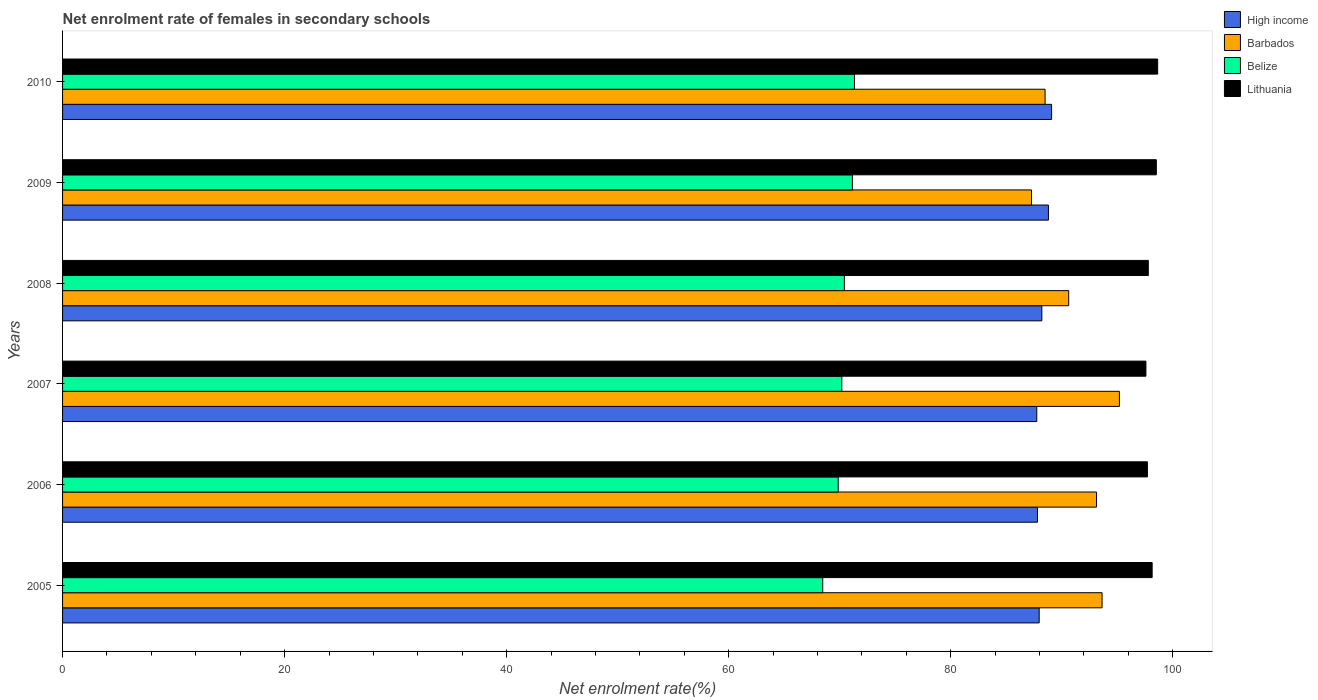How many groups of bars are there?
Provide a succinct answer. 6. Are the number of bars per tick equal to the number of legend labels?
Your response must be concise. Yes. Are the number of bars on each tick of the Y-axis equal?
Your answer should be very brief. Yes. How many bars are there on the 2nd tick from the bottom?
Provide a short and direct response. 4. What is the net enrolment rate of females in secondary schools in Barbados in 2008?
Ensure brevity in your answer.  90.63. Across all years, what is the maximum net enrolment rate of females in secondary schools in High income?
Keep it short and to the point. 89.08. Across all years, what is the minimum net enrolment rate of females in secondary schools in Lithuania?
Your answer should be compact. 97.58. In which year was the net enrolment rate of females in secondary schools in Belize minimum?
Ensure brevity in your answer.  2005. What is the total net enrolment rate of females in secondary schools in High income in the graph?
Give a very brief answer. 529.62. What is the difference between the net enrolment rate of females in secondary schools in Barbados in 2006 and that in 2010?
Offer a very short reply. 4.63. What is the difference between the net enrolment rate of females in secondary schools in High income in 2006 and the net enrolment rate of females in secondary schools in Barbados in 2009?
Give a very brief answer. 0.54. What is the average net enrolment rate of females in secondary schools in Lithuania per year?
Your answer should be very brief. 98.07. In the year 2009, what is the difference between the net enrolment rate of females in secondary schools in Belize and net enrolment rate of females in secondary schools in Barbados?
Offer a terse response. -16.13. What is the ratio of the net enrolment rate of females in secondary schools in High income in 2005 to that in 2006?
Give a very brief answer. 1. Is the net enrolment rate of females in secondary schools in Barbados in 2005 less than that in 2008?
Your answer should be very brief. No. Is the difference between the net enrolment rate of females in secondary schools in Belize in 2006 and 2010 greater than the difference between the net enrolment rate of females in secondary schools in Barbados in 2006 and 2010?
Offer a terse response. No. What is the difference between the highest and the second highest net enrolment rate of females in secondary schools in High income?
Provide a succinct answer. 0.28. What is the difference between the highest and the lowest net enrolment rate of females in secondary schools in Barbados?
Ensure brevity in your answer.  7.92. What does the 1st bar from the top in 2010 represents?
Offer a terse response. Lithuania. What does the 4th bar from the bottom in 2006 represents?
Provide a succinct answer. Lithuania. Is it the case that in every year, the sum of the net enrolment rate of females in secondary schools in High income and net enrolment rate of females in secondary schools in Belize is greater than the net enrolment rate of females in secondary schools in Lithuania?
Your answer should be very brief. Yes. What is the difference between two consecutive major ticks on the X-axis?
Keep it short and to the point. 20. Does the graph contain any zero values?
Provide a short and direct response. No. Does the graph contain grids?
Keep it short and to the point. No. Where does the legend appear in the graph?
Keep it short and to the point. Top right. How many legend labels are there?
Provide a succinct answer. 4. What is the title of the graph?
Keep it short and to the point. Net enrolment rate of females in secondary schools. Does "Guinea" appear as one of the legend labels in the graph?
Offer a terse response. No. What is the label or title of the X-axis?
Your response must be concise. Net enrolment rate(%). What is the Net enrolment rate(%) of High income in 2005?
Provide a short and direct response. 87.97. What is the Net enrolment rate(%) in Barbados in 2005?
Offer a very short reply. 93.63. What is the Net enrolment rate(%) in Belize in 2005?
Make the answer very short. 68.47. What is the Net enrolment rate(%) of Lithuania in 2005?
Offer a terse response. 98.14. What is the Net enrolment rate(%) in High income in 2006?
Keep it short and to the point. 87.81. What is the Net enrolment rate(%) in Barbados in 2006?
Your response must be concise. 93.13. What is the Net enrolment rate(%) in Belize in 2006?
Your answer should be compact. 69.87. What is the Net enrolment rate(%) of Lithuania in 2006?
Make the answer very short. 97.71. What is the Net enrolment rate(%) in High income in 2007?
Give a very brief answer. 87.75. What is the Net enrolment rate(%) in Barbados in 2007?
Your answer should be compact. 95.19. What is the Net enrolment rate(%) of Belize in 2007?
Your answer should be compact. 70.19. What is the Net enrolment rate(%) in Lithuania in 2007?
Make the answer very short. 97.58. What is the Net enrolment rate(%) in High income in 2008?
Your answer should be very brief. 88.21. What is the Net enrolment rate(%) in Barbados in 2008?
Keep it short and to the point. 90.63. What is the Net enrolment rate(%) of Belize in 2008?
Your answer should be compact. 70.42. What is the Net enrolment rate(%) of Lithuania in 2008?
Keep it short and to the point. 97.8. What is the Net enrolment rate(%) in High income in 2009?
Your answer should be compact. 88.8. What is the Net enrolment rate(%) of Barbados in 2009?
Give a very brief answer. 87.28. What is the Net enrolment rate(%) in Belize in 2009?
Provide a short and direct response. 71.14. What is the Net enrolment rate(%) of Lithuania in 2009?
Provide a short and direct response. 98.52. What is the Net enrolment rate(%) of High income in 2010?
Ensure brevity in your answer.  89.08. What is the Net enrolment rate(%) in Barbados in 2010?
Your response must be concise. 88.5. What is the Net enrolment rate(%) in Belize in 2010?
Ensure brevity in your answer.  71.33. What is the Net enrolment rate(%) in Lithuania in 2010?
Offer a very short reply. 98.64. Across all years, what is the maximum Net enrolment rate(%) of High income?
Ensure brevity in your answer.  89.08. Across all years, what is the maximum Net enrolment rate(%) in Barbados?
Your answer should be compact. 95.19. Across all years, what is the maximum Net enrolment rate(%) of Belize?
Offer a terse response. 71.33. Across all years, what is the maximum Net enrolment rate(%) of Lithuania?
Your answer should be very brief. 98.64. Across all years, what is the minimum Net enrolment rate(%) in High income?
Make the answer very short. 87.75. Across all years, what is the minimum Net enrolment rate(%) in Barbados?
Give a very brief answer. 87.28. Across all years, what is the minimum Net enrolment rate(%) in Belize?
Offer a very short reply. 68.47. Across all years, what is the minimum Net enrolment rate(%) in Lithuania?
Your answer should be very brief. 97.58. What is the total Net enrolment rate(%) in High income in the graph?
Make the answer very short. 529.62. What is the total Net enrolment rate(%) of Barbados in the graph?
Provide a short and direct response. 548.36. What is the total Net enrolment rate(%) in Belize in the graph?
Provide a short and direct response. 421.42. What is the total Net enrolment rate(%) in Lithuania in the graph?
Provide a succinct answer. 588.39. What is the difference between the Net enrolment rate(%) of High income in 2005 and that in 2006?
Keep it short and to the point. 0.15. What is the difference between the Net enrolment rate(%) of Barbados in 2005 and that in 2006?
Your answer should be very brief. 0.5. What is the difference between the Net enrolment rate(%) of Belize in 2005 and that in 2006?
Keep it short and to the point. -1.39. What is the difference between the Net enrolment rate(%) of Lithuania in 2005 and that in 2006?
Your response must be concise. 0.43. What is the difference between the Net enrolment rate(%) in High income in 2005 and that in 2007?
Make the answer very short. 0.22. What is the difference between the Net enrolment rate(%) in Barbados in 2005 and that in 2007?
Offer a terse response. -1.56. What is the difference between the Net enrolment rate(%) of Belize in 2005 and that in 2007?
Give a very brief answer. -1.72. What is the difference between the Net enrolment rate(%) in Lithuania in 2005 and that in 2007?
Offer a very short reply. 0.56. What is the difference between the Net enrolment rate(%) in High income in 2005 and that in 2008?
Offer a terse response. -0.24. What is the difference between the Net enrolment rate(%) in Barbados in 2005 and that in 2008?
Make the answer very short. 3.01. What is the difference between the Net enrolment rate(%) in Belize in 2005 and that in 2008?
Keep it short and to the point. -1.95. What is the difference between the Net enrolment rate(%) of Lithuania in 2005 and that in 2008?
Your answer should be compact. 0.35. What is the difference between the Net enrolment rate(%) of High income in 2005 and that in 2009?
Give a very brief answer. -0.83. What is the difference between the Net enrolment rate(%) of Barbados in 2005 and that in 2009?
Provide a short and direct response. 6.35. What is the difference between the Net enrolment rate(%) in Belize in 2005 and that in 2009?
Offer a very short reply. -2.67. What is the difference between the Net enrolment rate(%) in Lithuania in 2005 and that in 2009?
Your answer should be very brief. -0.38. What is the difference between the Net enrolment rate(%) in High income in 2005 and that in 2010?
Your response must be concise. -1.12. What is the difference between the Net enrolment rate(%) in Barbados in 2005 and that in 2010?
Give a very brief answer. 5.13. What is the difference between the Net enrolment rate(%) in Belize in 2005 and that in 2010?
Give a very brief answer. -2.86. What is the difference between the Net enrolment rate(%) of Lithuania in 2005 and that in 2010?
Your answer should be compact. -0.5. What is the difference between the Net enrolment rate(%) of High income in 2006 and that in 2007?
Your answer should be compact. 0.06. What is the difference between the Net enrolment rate(%) in Barbados in 2006 and that in 2007?
Your response must be concise. -2.06. What is the difference between the Net enrolment rate(%) of Belize in 2006 and that in 2007?
Make the answer very short. -0.32. What is the difference between the Net enrolment rate(%) in Lithuania in 2006 and that in 2007?
Your answer should be compact. 0.13. What is the difference between the Net enrolment rate(%) of High income in 2006 and that in 2008?
Your response must be concise. -0.39. What is the difference between the Net enrolment rate(%) in Barbados in 2006 and that in 2008?
Provide a succinct answer. 2.51. What is the difference between the Net enrolment rate(%) of Belize in 2006 and that in 2008?
Offer a terse response. -0.55. What is the difference between the Net enrolment rate(%) of Lithuania in 2006 and that in 2008?
Provide a short and direct response. -0.08. What is the difference between the Net enrolment rate(%) of High income in 2006 and that in 2009?
Give a very brief answer. -0.99. What is the difference between the Net enrolment rate(%) of Barbados in 2006 and that in 2009?
Provide a succinct answer. 5.86. What is the difference between the Net enrolment rate(%) in Belize in 2006 and that in 2009?
Your response must be concise. -1.28. What is the difference between the Net enrolment rate(%) in Lithuania in 2006 and that in 2009?
Provide a succinct answer. -0.8. What is the difference between the Net enrolment rate(%) of High income in 2006 and that in 2010?
Provide a short and direct response. -1.27. What is the difference between the Net enrolment rate(%) of Barbados in 2006 and that in 2010?
Your answer should be compact. 4.63. What is the difference between the Net enrolment rate(%) of Belize in 2006 and that in 2010?
Provide a short and direct response. -1.46. What is the difference between the Net enrolment rate(%) in Lithuania in 2006 and that in 2010?
Provide a succinct answer. -0.93. What is the difference between the Net enrolment rate(%) in High income in 2007 and that in 2008?
Offer a terse response. -0.46. What is the difference between the Net enrolment rate(%) in Barbados in 2007 and that in 2008?
Provide a short and direct response. 4.57. What is the difference between the Net enrolment rate(%) of Belize in 2007 and that in 2008?
Your answer should be very brief. -0.23. What is the difference between the Net enrolment rate(%) of Lithuania in 2007 and that in 2008?
Provide a succinct answer. -0.21. What is the difference between the Net enrolment rate(%) in High income in 2007 and that in 2009?
Give a very brief answer. -1.05. What is the difference between the Net enrolment rate(%) in Barbados in 2007 and that in 2009?
Ensure brevity in your answer.  7.92. What is the difference between the Net enrolment rate(%) of Belize in 2007 and that in 2009?
Offer a terse response. -0.95. What is the difference between the Net enrolment rate(%) in Lithuania in 2007 and that in 2009?
Offer a very short reply. -0.94. What is the difference between the Net enrolment rate(%) of High income in 2007 and that in 2010?
Provide a succinct answer. -1.33. What is the difference between the Net enrolment rate(%) of Barbados in 2007 and that in 2010?
Provide a succinct answer. 6.69. What is the difference between the Net enrolment rate(%) of Belize in 2007 and that in 2010?
Make the answer very short. -1.14. What is the difference between the Net enrolment rate(%) of Lithuania in 2007 and that in 2010?
Offer a terse response. -1.06. What is the difference between the Net enrolment rate(%) in High income in 2008 and that in 2009?
Your answer should be compact. -0.59. What is the difference between the Net enrolment rate(%) in Barbados in 2008 and that in 2009?
Provide a short and direct response. 3.35. What is the difference between the Net enrolment rate(%) of Belize in 2008 and that in 2009?
Make the answer very short. -0.72. What is the difference between the Net enrolment rate(%) of Lithuania in 2008 and that in 2009?
Offer a very short reply. -0.72. What is the difference between the Net enrolment rate(%) in High income in 2008 and that in 2010?
Keep it short and to the point. -0.88. What is the difference between the Net enrolment rate(%) in Barbados in 2008 and that in 2010?
Your answer should be compact. 2.13. What is the difference between the Net enrolment rate(%) in Belize in 2008 and that in 2010?
Your answer should be very brief. -0.91. What is the difference between the Net enrolment rate(%) in Lithuania in 2008 and that in 2010?
Provide a short and direct response. -0.84. What is the difference between the Net enrolment rate(%) in High income in 2009 and that in 2010?
Ensure brevity in your answer.  -0.28. What is the difference between the Net enrolment rate(%) of Barbados in 2009 and that in 2010?
Your answer should be very brief. -1.22. What is the difference between the Net enrolment rate(%) of Belize in 2009 and that in 2010?
Your response must be concise. -0.19. What is the difference between the Net enrolment rate(%) of Lithuania in 2009 and that in 2010?
Your response must be concise. -0.12. What is the difference between the Net enrolment rate(%) in High income in 2005 and the Net enrolment rate(%) in Barbados in 2006?
Offer a terse response. -5.17. What is the difference between the Net enrolment rate(%) of High income in 2005 and the Net enrolment rate(%) of Belize in 2006?
Offer a very short reply. 18.1. What is the difference between the Net enrolment rate(%) of High income in 2005 and the Net enrolment rate(%) of Lithuania in 2006?
Your response must be concise. -9.75. What is the difference between the Net enrolment rate(%) in Barbados in 2005 and the Net enrolment rate(%) in Belize in 2006?
Provide a succinct answer. 23.77. What is the difference between the Net enrolment rate(%) in Barbados in 2005 and the Net enrolment rate(%) in Lithuania in 2006?
Ensure brevity in your answer.  -4.08. What is the difference between the Net enrolment rate(%) in Belize in 2005 and the Net enrolment rate(%) in Lithuania in 2006?
Your answer should be compact. -29.24. What is the difference between the Net enrolment rate(%) in High income in 2005 and the Net enrolment rate(%) in Barbados in 2007?
Provide a succinct answer. -7.23. What is the difference between the Net enrolment rate(%) in High income in 2005 and the Net enrolment rate(%) in Belize in 2007?
Your answer should be compact. 17.78. What is the difference between the Net enrolment rate(%) in High income in 2005 and the Net enrolment rate(%) in Lithuania in 2007?
Provide a short and direct response. -9.61. What is the difference between the Net enrolment rate(%) in Barbados in 2005 and the Net enrolment rate(%) in Belize in 2007?
Offer a very short reply. 23.44. What is the difference between the Net enrolment rate(%) in Barbados in 2005 and the Net enrolment rate(%) in Lithuania in 2007?
Provide a short and direct response. -3.95. What is the difference between the Net enrolment rate(%) in Belize in 2005 and the Net enrolment rate(%) in Lithuania in 2007?
Offer a very short reply. -29.11. What is the difference between the Net enrolment rate(%) in High income in 2005 and the Net enrolment rate(%) in Barbados in 2008?
Provide a short and direct response. -2.66. What is the difference between the Net enrolment rate(%) of High income in 2005 and the Net enrolment rate(%) of Belize in 2008?
Provide a short and direct response. 17.55. What is the difference between the Net enrolment rate(%) of High income in 2005 and the Net enrolment rate(%) of Lithuania in 2008?
Keep it short and to the point. -9.83. What is the difference between the Net enrolment rate(%) in Barbados in 2005 and the Net enrolment rate(%) in Belize in 2008?
Your response must be concise. 23.21. What is the difference between the Net enrolment rate(%) of Barbados in 2005 and the Net enrolment rate(%) of Lithuania in 2008?
Offer a very short reply. -4.17. What is the difference between the Net enrolment rate(%) of Belize in 2005 and the Net enrolment rate(%) of Lithuania in 2008?
Provide a short and direct response. -29.33. What is the difference between the Net enrolment rate(%) of High income in 2005 and the Net enrolment rate(%) of Barbados in 2009?
Keep it short and to the point. 0.69. What is the difference between the Net enrolment rate(%) in High income in 2005 and the Net enrolment rate(%) in Belize in 2009?
Offer a very short reply. 16.83. What is the difference between the Net enrolment rate(%) in High income in 2005 and the Net enrolment rate(%) in Lithuania in 2009?
Ensure brevity in your answer.  -10.55. What is the difference between the Net enrolment rate(%) of Barbados in 2005 and the Net enrolment rate(%) of Belize in 2009?
Offer a very short reply. 22.49. What is the difference between the Net enrolment rate(%) of Barbados in 2005 and the Net enrolment rate(%) of Lithuania in 2009?
Provide a short and direct response. -4.89. What is the difference between the Net enrolment rate(%) of Belize in 2005 and the Net enrolment rate(%) of Lithuania in 2009?
Provide a succinct answer. -30.05. What is the difference between the Net enrolment rate(%) in High income in 2005 and the Net enrolment rate(%) in Barbados in 2010?
Offer a very short reply. -0.53. What is the difference between the Net enrolment rate(%) of High income in 2005 and the Net enrolment rate(%) of Belize in 2010?
Provide a succinct answer. 16.64. What is the difference between the Net enrolment rate(%) in High income in 2005 and the Net enrolment rate(%) in Lithuania in 2010?
Provide a succinct answer. -10.67. What is the difference between the Net enrolment rate(%) of Barbados in 2005 and the Net enrolment rate(%) of Belize in 2010?
Offer a terse response. 22.3. What is the difference between the Net enrolment rate(%) of Barbados in 2005 and the Net enrolment rate(%) of Lithuania in 2010?
Keep it short and to the point. -5.01. What is the difference between the Net enrolment rate(%) in Belize in 2005 and the Net enrolment rate(%) in Lithuania in 2010?
Your response must be concise. -30.17. What is the difference between the Net enrolment rate(%) of High income in 2006 and the Net enrolment rate(%) of Barbados in 2007?
Provide a short and direct response. -7.38. What is the difference between the Net enrolment rate(%) of High income in 2006 and the Net enrolment rate(%) of Belize in 2007?
Your answer should be very brief. 17.62. What is the difference between the Net enrolment rate(%) of High income in 2006 and the Net enrolment rate(%) of Lithuania in 2007?
Your answer should be very brief. -9.77. What is the difference between the Net enrolment rate(%) in Barbados in 2006 and the Net enrolment rate(%) in Belize in 2007?
Provide a short and direct response. 22.94. What is the difference between the Net enrolment rate(%) in Barbados in 2006 and the Net enrolment rate(%) in Lithuania in 2007?
Give a very brief answer. -4.45. What is the difference between the Net enrolment rate(%) of Belize in 2006 and the Net enrolment rate(%) of Lithuania in 2007?
Ensure brevity in your answer.  -27.72. What is the difference between the Net enrolment rate(%) of High income in 2006 and the Net enrolment rate(%) of Barbados in 2008?
Offer a terse response. -2.81. What is the difference between the Net enrolment rate(%) of High income in 2006 and the Net enrolment rate(%) of Belize in 2008?
Give a very brief answer. 17.39. What is the difference between the Net enrolment rate(%) in High income in 2006 and the Net enrolment rate(%) in Lithuania in 2008?
Provide a succinct answer. -9.98. What is the difference between the Net enrolment rate(%) in Barbados in 2006 and the Net enrolment rate(%) in Belize in 2008?
Your response must be concise. 22.71. What is the difference between the Net enrolment rate(%) of Barbados in 2006 and the Net enrolment rate(%) of Lithuania in 2008?
Give a very brief answer. -4.66. What is the difference between the Net enrolment rate(%) of Belize in 2006 and the Net enrolment rate(%) of Lithuania in 2008?
Your response must be concise. -27.93. What is the difference between the Net enrolment rate(%) of High income in 2006 and the Net enrolment rate(%) of Barbados in 2009?
Your answer should be compact. 0.54. What is the difference between the Net enrolment rate(%) of High income in 2006 and the Net enrolment rate(%) of Belize in 2009?
Your response must be concise. 16.67. What is the difference between the Net enrolment rate(%) in High income in 2006 and the Net enrolment rate(%) in Lithuania in 2009?
Provide a short and direct response. -10.71. What is the difference between the Net enrolment rate(%) in Barbados in 2006 and the Net enrolment rate(%) in Belize in 2009?
Your answer should be compact. 21.99. What is the difference between the Net enrolment rate(%) of Barbados in 2006 and the Net enrolment rate(%) of Lithuania in 2009?
Your answer should be compact. -5.39. What is the difference between the Net enrolment rate(%) in Belize in 2006 and the Net enrolment rate(%) in Lithuania in 2009?
Provide a short and direct response. -28.65. What is the difference between the Net enrolment rate(%) of High income in 2006 and the Net enrolment rate(%) of Barbados in 2010?
Provide a short and direct response. -0.69. What is the difference between the Net enrolment rate(%) in High income in 2006 and the Net enrolment rate(%) in Belize in 2010?
Ensure brevity in your answer.  16.48. What is the difference between the Net enrolment rate(%) in High income in 2006 and the Net enrolment rate(%) in Lithuania in 2010?
Keep it short and to the point. -10.83. What is the difference between the Net enrolment rate(%) in Barbados in 2006 and the Net enrolment rate(%) in Belize in 2010?
Keep it short and to the point. 21.8. What is the difference between the Net enrolment rate(%) in Barbados in 2006 and the Net enrolment rate(%) in Lithuania in 2010?
Provide a short and direct response. -5.51. What is the difference between the Net enrolment rate(%) of Belize in 2006 and the Net enrolment rate(%) of Lithuania in 2010?
Ensure brevity in your answer.  -28.77. What is the difference between the Net enrolment rate(%) of High income in 2007 and the Net enrolment rate(%) of Barbados in 2008?
Give a very brief answer. -2.88. What is the difference between the Net enrolment rate(%) in High income in 2007 and the Net enrolment rate(%) in Belize in 2008?
Your response must be concise. 17.33. What is the difference between the Net enrolment rate(%) of High income in 2007 and the Net enrolment rate(%) of Lithuania in 2008?
Offer a terse response. -10.05. What is the difference between the Net enrolment rate(%) of Barbados in 2007 and the Net enrolment rate(%) of Belize in 2008?
Offer a terse response. 24.77. What is the difference between the Net enrolment rate(%) in Barbados in 2007 and the Net enrolment rate(%) in Lithuania in 2008?
Give a very brief answer. -2.6. What is the difference between the Net enrolment rate(%) in Belize in 2007 and the Net enrolment rate(%) in Lithuania in 2008?
Make the answer very short. -27.61. What is the difference between the Net enrolment rate(%) in High income in 2007 and the Net enrolment rate(%) in Barbados in 2009?
Provide a short and direct response. 0.47. What is the difference between the Net enrolment rate(%) of High income in 2007 and the Net enrolment rate(%) of Belize in 2009?
Offer a very short reply. 16.61. What is the difference between the Net enrolment rate(%) of High income in 2007 and the Net enrolment rate(%) of Lithuania in 2009?
Offer a terse response. -10.77. What is the difference between the Net enrolment rate(%) of Barbados in 2007 and the Net enrolment rate(%) of Belize in 2009?
Your response must be concise. 24.05. What is the difference between the Net enrolment rate(%) of Barbados in 2007 and the Net enrolment rate(%) of Lithuania in 2009?
Your answer should be compact. -3.33. What is the difference between the Net enrolment rate(%) in Belize in 2007 and the Net enrolment rate(%) in Lithuania in 2009?
Your response must be concise. -28.33. What is the difference between the Net enrolment rate(%) in High income in 2007 and the Net enrolment rate(%) in Barbados in 2010?
Offer a very short reply. -0.75. What is the difference between the Net enrolment rate(%) of High income in 2007 and the Net enrolment rate(%) of Belize in 2010?
Offer a terse response. 16.42. What is the difference between the Net enrolment rate(%) in High income in 2007 and the Net enrolment rate(%) in Lithuania in 2010?
Your answer should be compact. -10.89. What is the difference between the Net enrolment rate(%) of Barbados in 2007 and the Net enrolment rate(%) of Belize in 2010?
Keep it short and to the point. 23.86. What is the difference between the Net enrolment rate(%) of Barbados in 2007 and the Net enrolment rate(%) of Lithuania in 2010?
Give a very brief answer. -3.45. What is the difference between the Net enrolment rate(%) of Belize in 2007 and the Net enrolment rate(%) of Lithuania in 2010?
Ensure brevity in your answer.  -28.45. What is the difference between the Net enrolment rate(%) in High income in 2008 and the Net enrolment rate(%) in Barbados in 2009?
Ensure brevity in your answer.  0.93. What is the difference between the Net enrolment rate(%) in High income in 2008 and the Net enrolment rate(%) in Belize in 2009?
Your answer should be very brief. 17.06. What is the difference between the Net enrolment rate(%) of High income in 2008 and the Net enrolment rate(%) of Lithuania in 2009?
Your answer should be compact. -10.31. What is the difference between the Net enrolment rate(%) of Barbados in 2008 and the Net enrolment rate(%) of Belize in 2009?
Make the answer very short. 19.48. What is the difference between the Net enrolment rate(%) in Barbados in 2008 and the Net enrolment rate(%) in Lithuania in 2009?
Give a very brief answer. -7.89. What is the difference between the Net enrolment rate(%) of Belize in 2008 and the Net enrolment rate(%) of Lithuania in 2009?
Keep it short and to the point. -28.1. What is the difference between the Net enrolment rate(%) in High income in 2008 and the Net enrolment rate(%) in Barbados in 2010?
Provide a short and direct response. -0.29. What is the difference between the Net enrolment rate(%) of High income in 2008 and the Net enrolment rate(%) of Belize in 2010?
Your answer should be compact. 16.88. What is the difference between the Net enrolment rate(%) in High income in 2008 and the Net enrolment rate(%) in Lithuania in 2010?
Make the answer very short. -10.43. What is the difference between the Net enrolment rate(%) of Barbados in 2008 and the Net enrolment rate(%) of Belize in 2010?
Make the answer very short. 19.3. What is the difference between the Net enrolment rate(%) in Barbados in 2008 and the Net enrolment rate(%) in Lithuania in 2010?
Offer a very short reply. -8.01. What is the difference between the Net enrolment rate(%) in Belize in 2008 and the Net enrolment rate(%) in Lithuania in 2010?
Give a very brief answer. -28.22. What is the difference between the Net enrolment rate(%) of High income in 2009 and the Net enrolment rate(%) of Barbados in 2010?
Make the answer very short. 0.3. What is the difference between the Net enrolment rate(%) in High income in 2009 and the Net enrolment rate(%) in Belize in 2010?
Your response must be concise. 17.47. What is the difference between the Net enrolment rate(%) in High income in 2009 and the Net enrolment rate(%) in Lithuania in 2010?
Ensure brevity in your answer.  -9.84. What is the difference between the Net enrolment rate(%) in Barbados in 2009 and the Net enrolment rate(%) in Belize in 2010?
Offer a terse response. 15.95. What is the difference between the Net enrolment rate(%) in Barbados in 2009 and the Net enrolment rate(%) in Lithuania in 2010?
Provide a short and direct response. -11.36. What is the difference between the Net enrolment rate(%) in Belize in 2009 and the Net enrolment rate(%) in Lithuania in 2010?
Offer a terse response. -27.5. What is the average Net enrolment rate(%) in High income per year?
Offer a terse response. 88.27. What is the average Net enrolment rate(%) in Barbados per year?
Your response must be concise. 91.39. What is the average Net enrolment rate(%) of Belize per year?
Give a very brief answer. 70.24. What is the average Net enrolment rate(%) in Lithuania per year?
Keep it short and to the point. 98.07. In the year 2005, what is the difference between the Net enrolment rate(%) of High income and Net enrolment rate(%) of Barbados?
Your answer should be very brief. -5.66. In the year 2005, what is the difference between the Net enrolment rate(%) in High income and Net enrolment rate(%) in Belize?
Offer a very short reply. 19.5. In the year 2005, what is the difference between the Net enrolment rate(%) in High income and Net enrolment rate(%) in Lithuania?
Ensure brevity in your answer.  -10.18. In the year 2005, what is the difference between the Net enrolment rate(%) of Barbados and Net enrolment rate(%) of Belize?
Ensure brevity in your answer.  25.16. In the year 2005, what is the difference between the Net enrolment rate(%) in Barbados and Net enrolment rate(%) in Lithuania?
Keep it short and to the point. -4.51. In the year 2005, what is the difference between the Net enrolment rate(%) in Belize and Net enrolment rate(%) in Lithuania?
Offer a terse response. -29.67. In the year 2006, what is the difference between the Net enrolment rate(%) in High income and Net enrolment rate(%) in Barbados?
Provide a short and direct response. -5.32. In the year 2006, what is the difference between the Net enrolment rate(%) of High income and Net enrolment rate(%) of Belize?
Your response must be concise. 17.95. In the year 2006, what is the difference between the Net enrolment rate(%) in High income and Net enrolment rate(%) in Lithuania?
Give a very brief answer. -9.9. In the year 2006, what is the difference between the Net enrolment rate(%) in Barbados and Net enrolment rate(%) in Belize?
Keep it short and to the point. 23.27. In the year 2006, what is the difference between the Net enrolment rate(%) of Barbados and Net enrolment rate(%) of Lithuania?
Your response must be concise. -4.58. In the year 2006, what is the difference between the Net enrolment rate(%) of Belize and Net enrolment rate(%) of Lithuania?
Keep it short and to the point. -27.85. In the year 2007, what is the difference between the Net enrolment rate(%) of High income and Net enrolment rate(%) of Barbados?
Keep it short and to the point. -7.44. In the year 2007, what is the difference between the Net enrolment rate(%) in High income and Net enrolment rate(%) in Belize?
Provide a short and direct response. 17.56. In the year 2007, what is the difference between the Net enrolment rate(%) of High income and Net enrolment rate(%) of Lithuania?
Offer a terse response. -9.83. In the year 2007, what is the difference between the Net enrolment rate(%) in Barbados and Net enrolment rate(%) in Belize?
Provide a short and direct response. 25. In the year 2007, what is the difference between the Net enrolment rate(%) of Barbados and Net enrolment rate(%) of Lithuania?
Offer a very short reply. -2.39. In the year 2007, what is the difference between the Net enrolment rate(%) of Belize and Net enrolment rate(%) of Lithuania?
Your answer should be very brief. -27.39. In the year 2008, what is the difference between the Net enrolment rate(%) in High income and Net enrolment rate(%) in Barbados?
Offer a terse response. -2.42. In the year 2008, what is the difference between the Net enrolment rate(%) of High income and Net enrolment rate(%) of Belize?
Your answer should be very brief. 17.79. In the year 2008, what is the difference between the Net enrolment rate(%) of High income and Net enrolment rate(%) of Lithuania?
Offer a very short reply. -9.59. In the year 2008, what is the difference between the Net enrolment rate(%) in Barbados and Net enrolment rate(%) in Belize?
Offer a very short reply. 20.21. In the year 2008, what is the difference between the Net enrolment rate(%) of Barbados and Net enrolment rate(%) of Lithuania?
Make the answer very short. -7.17. In the year 2008, what is the difference between the Net enrolment rate(%) of Belize and Net enrolment rate(%) of Lithuania?
Make the answer very short. -27.38. In the year 2009, what is the difference between the Net enrolment rate(%) of High income and Net enrolment rate(%) of Barbados?
Keep it short and to the point. 1.52. In the year 2009, what is the difference between the Net enrolment rate(%) in High income and Net enrolment rate(%) in Belize?
Make the answer very short. 17.66. In the year 2009, what is the difference between the Net enrolment rate(%) in High income and Net enrolment rate(%) in Lithuania?
Your response must be concise. -9.72. In the year 2009, what is the difference between the Net enrolment rate(%) in Barbados and Net enrolment rate(%) in Belize?
Give a very brief answer. 16.13. In the year 2009, what is the difference between the Net enrolment rate(%) in Barbados and Net enrolment rate(%) in Lithuania?
Make the answer very short. -11.24. In the year 2009, what is the difference between the Net enrolment rate(%) of Belize and Net enrolment rate(%) of Lithuania?
Provide a succinct answer. -27.38. In the year 2010, what is the difference between the Net enrolment rate(%) of High income and Net enrolment rate(%) of Barbados?
Give a very brief answer. 0.59. In the year 2010, what is the difference between the Net enrolment rate(%) in High income and Net enrolment rate(%) in Belize?
Provide a succinct answer. 17.76. In the year 2010, what is the difference between the Net enrolment rate(%) of High income and Net enrolment rate(%) of Lithuania?
Your answer should be compact. -9.56. In the year 2010, what is the difference between the Net enrolment rate(%) in Barbados and Net enrolment rate(%) in Belize?
Your answer should be compact. 17.17. In the year 2010, what is the difference between the Net enrolment rate(%) of Barbados and Net enrolment rate(%) of Lithuania?
Your answer should be very brief. -10.14. In the year 2010, what is the difference between the Net enrolment rate(%) of Belize and Net enrolment rate(%) of Lithuania?
Your response must be concise. -27.31. What is the ratio of the Net enrolment rate(%) in High income in 2005 to that in 2006?
Keep it short and to the point. 1. What is the ratio of the Net enrolment rate(%) in Barbados in 2005 to that in 2006?
Your answer should be compact. 1.01. What is the ratio of the Net enrolment rate(%) in Barbados in 2005 to that in 2007?
Make the answer very short. 0.98. What is the ratio of the Net enrolment rate(%) in Belize in 2005 to that in 2007?
Provide a succinct answer. 0.98. What is the ratio of the Net enrolment rate(%) of Lithuania in 2005 to that in 2007?
Your answer should be very brief. 1.01. What is the ratio of the Net enrolment rate(%) in High income in 2005 to that in 2008?
Ensure brevity in your answer.  1. What is the ratio of the Net enrolment rate(%) in Barbados in 2005 to that in 2008?
Give a very brief answer. 1.03. What is the ratio of the Net enrolment rate(%) of Belize in 2005 to that in 2008?
Ensure brevity in your answer.  0.97. What is the ratio of the Net enrolment rate(%) of High income in 2005 to that in 2009?
Your answer should be very brief. 0.99. What is the ratio of the Net enrolment rate(%) in Barbados in 2005 to that in 2009?
Your answer should be very brief. 1.07. What is the ratio of the Net enrolment rate(%) of Belize in 2005 to that in 2009?
Keep it short and to the point. 0.96. What is the ratio of the Net enrolment rate(%) in Lithuania in 2005 to that in 2009?
Keep it short and to the point. 1. What is the ratio of the Net enrolment rate(%) in High income in 2005 to that in 2010?
Your answer should be compact. 0.99. What is the ratio of the Net enrolment rate(%) in Barbados in 2005 to that in 2010?
Provide a short and direct response. 1.06. What is the ratio of the Net enrolment rate(%) of Belize in 2005 to that in 2010?
Offer a terse response. 0.96. What is the ratio of the Net enrolment rate(%) of Barbados in 2006 to that in 2007?
Keep it short and to the point. 0.98. What is the ratio of the Net enrolment rate(%) in High income in 2006 to that in 2008?
Give a very brief answer. 1. What is the ratio of the Net enrolment rate(%) in Barbados in 2006 to that in 2008?
Provide a succinct answer. 1.03. What is the ratio of the Net enrolment rate(%) of Belize in 2006 to that in 2008?
Your answer should be very brief. 0.99. What is the ratio of the Net enrolment rate(%) of Lithuania in 2006 to that in 2008?
Offer a terse response. 1. What is the ratio of the Net enrolment rate(%) of High income in 2006 to that in 2009?
Provide a short and direct response. 0.99. What is the ratio of the Net enrolment rate(%) in Barbados in 2006 to that in 2009?
Your response must be concise. 1.07. What is the ratio of the Net enrolment rate(%) of Belize in 2006 to that in 2009?
Ensure brevity in your answer.  0.98. What is the ratio of the Net enrolment rate(%) of High income in 2006 to that in 2010?
Your answer should be very brief. 0.99. What is the ratio of the Net enrolment rate(%) in Barbados in 2006 to that in 2010?
Offer a terse response. 1.05. What is the ratio of the Net enrolment rate(%) of Belize in 2006 to that in 2010?
Keep it short and to the point. 0.98. What is the ratio of the Net enrolment rate(%) of Lithuania in 2006 to that in 2010?
Offer a terse response. 0.99. What is the ratio of the Net enrolment rate(%) of Barbados in 2007 to that in 2008?
Your answer should be very brief. 1.05. What is the ratio of the Net enrolment rate(%) in Belize in 2007 to that in 2008?
Keep it short and to the point. 1. What is the ratio of the Net enrolment rate(%) in High income in 2007 to that in 2009?
Offer a very short reply. 0.99. What is the ratio of the Net enrolment rate(%) of Barbados in 2007 to that in 2009?
Give a very brief answer. 1.09. What is the ratio of the Net enrolment rate(%) in Belize in 2007 to that in 2009?
Your answer should be very brief. 0.99. What is the ratio of the Net enrolment rate(%) of Barbados in 2007 to that in 2010?
Your answer should be very brief. 1.08. What is the ratio of the Net enrolment rate(%) of Lithuania in 2007 to that in 2010?
Provide a short and direct response. 0.99. What is the ratio of the Net enrolment rate(%) of High income in 2008 to that in 2009?
Your answer should be compact. 0.99. What is the ratio of the Net enrolment rate(%) of Barbados in 2008 to that in 2009?
Your answer should be very brief. 1.04. What is the ratio of the Net enrolment rate(%) in Belize in 2008 to that in 2009?
Provide a succinct answer. 0.99. What is the ratio of the Net enrolment rate(%) in Belize in 2008 to that in 2010?
Provide a succinct answer. 0.99. What is the ratio of the Net enrolment rate(%) in Lithuania in 2008 to that in 2010?
Provide a short and direct response. 0.99. What is the ratio of the Net enrolment rate(%) of High income in 2009 to that in 2010?
Make the answer very short. 1. What is the ratio of the Net enrolment rate(%) of Barbados in 2009 to that in 2010?
Make the answer very short. 0.99. What is the difference between the highest and the second highest Net enrolment rate(%) of High income?
Keep it short and to the point. 0.28. What is the difference between the highest and the second highest Net enrolment rate(%) of Barbados?
Your answer should be very brief. 1.56. What is the difference between the highest and the second highest Net enrolment rate(%) in Belize?
Keep it short and to the point. 0.19. What is the difference between the highest and the second highest Net enrolment rate(%) of Lithuania?
Provide a short and direct response. 0.12. What is the difference between the highest and the lowest Net enrolment rate(%) in High income?
Offer a very short reply. 1.33. What is the difference between the highest and the lowest Net enrolment rate(%) in Barbados?
Provide a succinct answer. 7.92. What is the difference between the highest and the lowest Net enrolment rate(%) of Belize?
Provide a succinct answer. 2.86. What is the difference between the highest and the lowest Net enrolment rate(%) in Lithuania?
Make the answer very short. 1.06. 